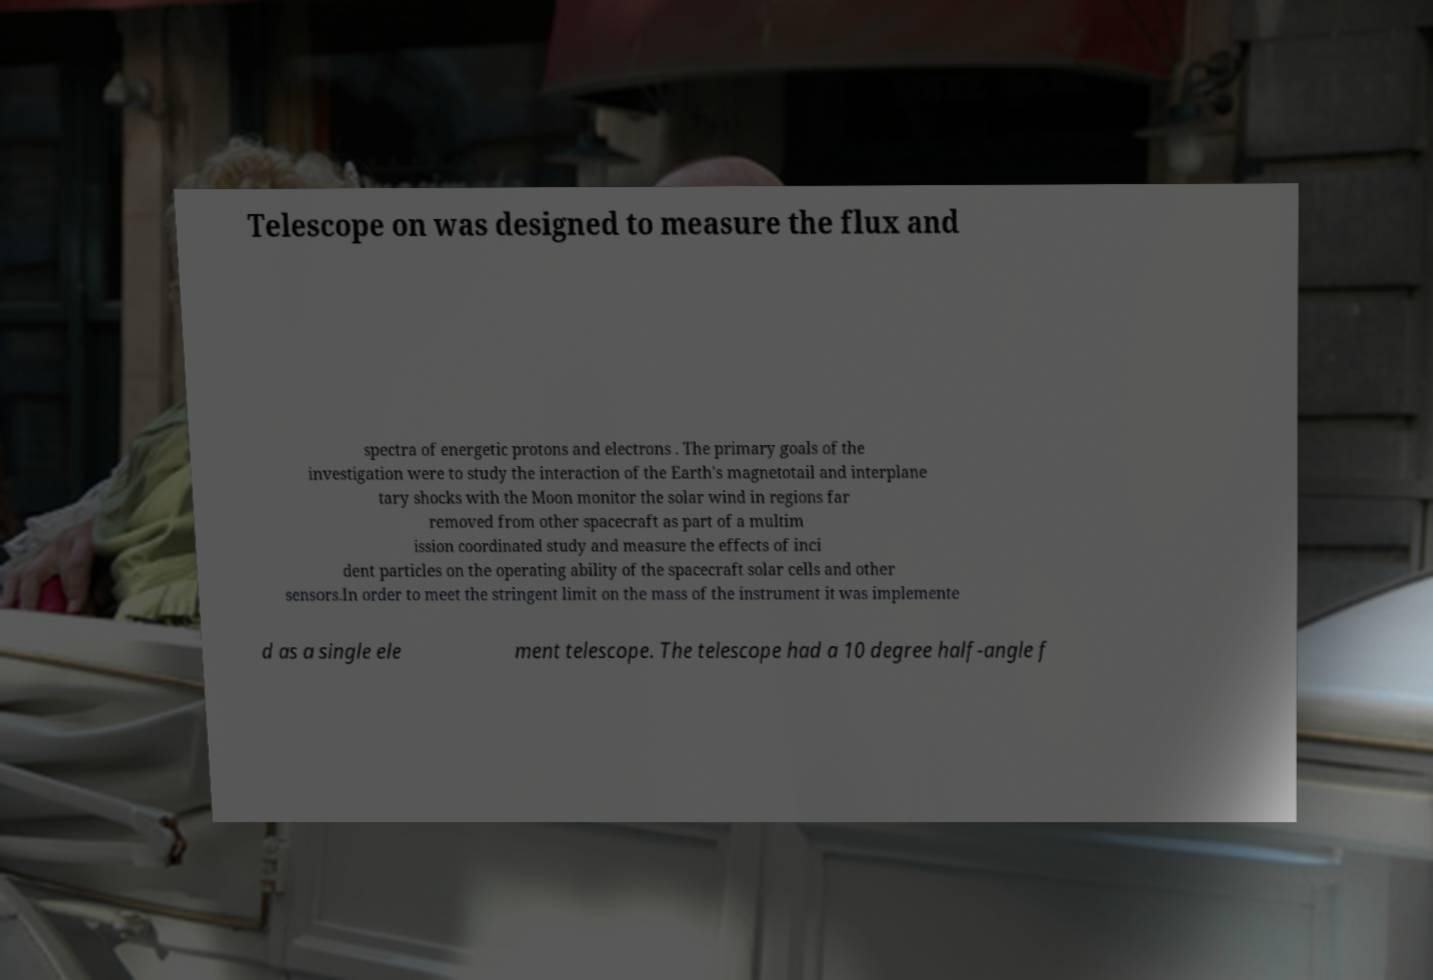What messages or text are displayed in this image? I need them in a readable, typed format. Telescope on was designed to measure the flux and spectra of energetic protons and electrons . The primary goals of the investigation were to study the interaction of the Earth's magnetotail and interplane tary shocks with the Moon monitor the solar wind in regions far removed from other spacecraft as part of a multim ission coordinated study and measure the effects of inci dent particles on the operating ability of the spacecraft solar cells and other sensors.In order to meet the stringent limit on the mass of the instrument it was implemente d as a single ele ment telescope. The telescope had a 10 degree half-angle f 